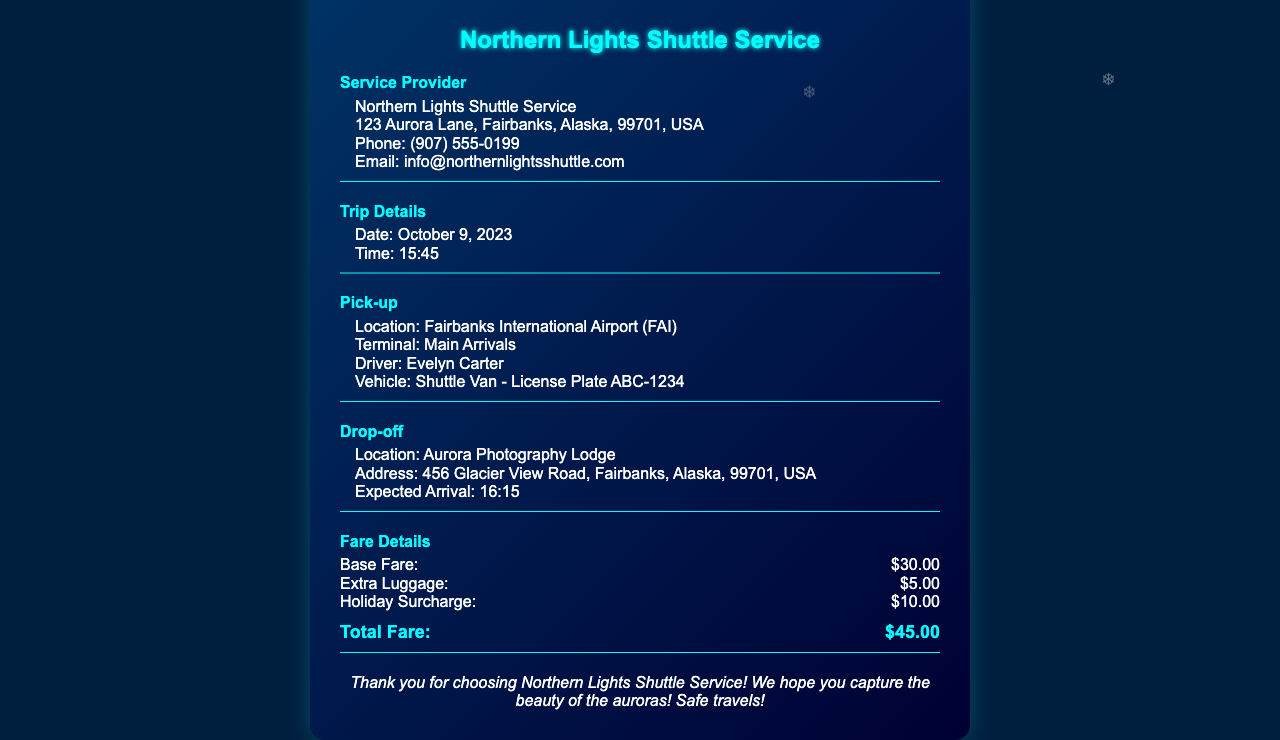What is the name of the service provider? The service provider's name is listed in the document as the entity providing the shuttle service.
Answer: Northern Lights Shuttle Service What is the pick-up location? The pick-up location is specified in the document, indicating where the shuttle begins its journey.
Answer: Fairbanks International Airport (FAI) What is the date of the trip? The document specifies the date on which the shuttle service was provided.
Answer: October 9, 2023 Who is the driver of the shuttle? The name of the driver is mentioned, providing specific information about the personnel involved.
Answer: Evelyn Carter What is the total fare? The total fare is calculated by summing up the individual charges as shown in the fare details section.
Answer: $45.00 What is the expected arrival time at the drop-off location? The document includes the expected time of arrival at the drop-off point.
Answer: 16:15 How much is the holiday surcharge? The document specifies this additional fee applied during holidays, contributing to the overall fare.
Answer: $10.00 What vehicle type is used for the shuttle service? The type of vehicle is described in the document, indicating what passengers can expect during the trip.
Answer: Shuttle Van What address is the drop-off location? The document provides the full address where passengers will be dropped off.
Answer: 456 Glacier View Road, Fairbanks, Alaska, 99701, USA 